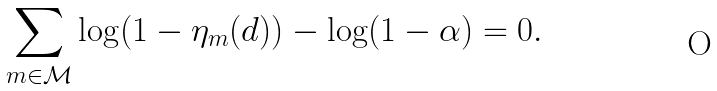<formula> <loc_0><loc_0><loc_500><loc_500>\sum _ { m \in \mathcal { M } } \log ( 1 - \eta _ { m } ( d ) ) - \log ( 1 - \alpha ) = 0 .</formula> 